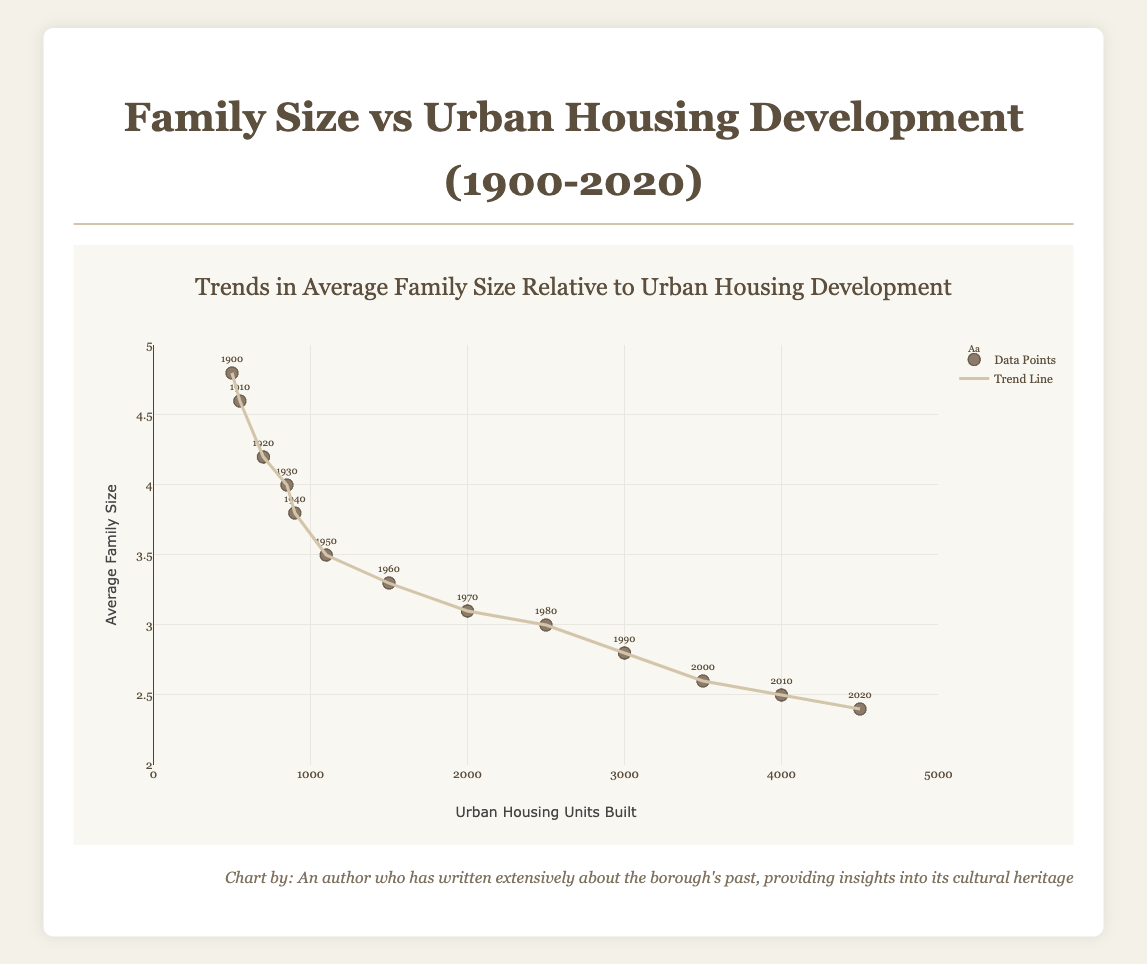What's the title of the plot? The title is located at the top center of the plot, written in a larger font size compared to other texts. It provides a summary of the data being presented.
Answer: Family Size vs Urban Housing Development (1900-2020) What does the x-axis represent? The x-axis represents the variable which is plotting the horizontal values. In this plot, it captures the number of "Urban Housing Units Built".
Answer: Urban Housing Units Built How many data points are represented in the scatter plot? Each data point represents a specific year and is marked on the scatter plot. By counting the individual points, we can determine the total number. There are markers for each decade from 1900 to 2020.
Answer: 13 What is the trend in average family size as more urban housing units are built? Observing the trend line helps understand how average family size changes with the increasing number of urban housing units. The trend line slopes downward, indicating a decrease in average family size as urban housing development increases.
Answer: Decrease What is the average family size in the year 1950? To find this, locate the point labeled "1950" on the scatter plot and check its corresponding y-axis value.
Answer: 3.5 Which year shows the highest average family size? Reviewing the scatter plot, the highest data point on the y-axis denotes the maximum average family size. This point, when traced horizontally, matches the year 1900.
Answer: 1900 By how much did the average family size decrease from 1900 to 2020? First, find the average family sizes for 1900 (4.8) and 2020 (2.4) and then calculate their difference. Subtract the average family size in 2020 from that in 1900: 4.8 - 2.4.
Answer: 2.4 In which decade was there the largest increase in urban housing units built? Find the difference in the number of urban housing units built between decades and identify when the most significant increase occurred. From 1960 (1500) to 1970 (2000), units increased by 500, the most significant rise compared with other decades.
Answer: 1960s to 1970s What is the correlation between urban housing units built and average family size? In scatter plots with a trend line, the nature of the line (positive/negative slope) indicates whether the correlation is positive or negative. Here, a downward sloping line suggests a negative correlation.
Answer: Negative Which decade saw a shift to an average family size of 3 or fewer people? Reviewing each decade's data points and their corresponding y-axis values, the family size drops to 3 or fewer starting in 1980.
Answer: 1980s 